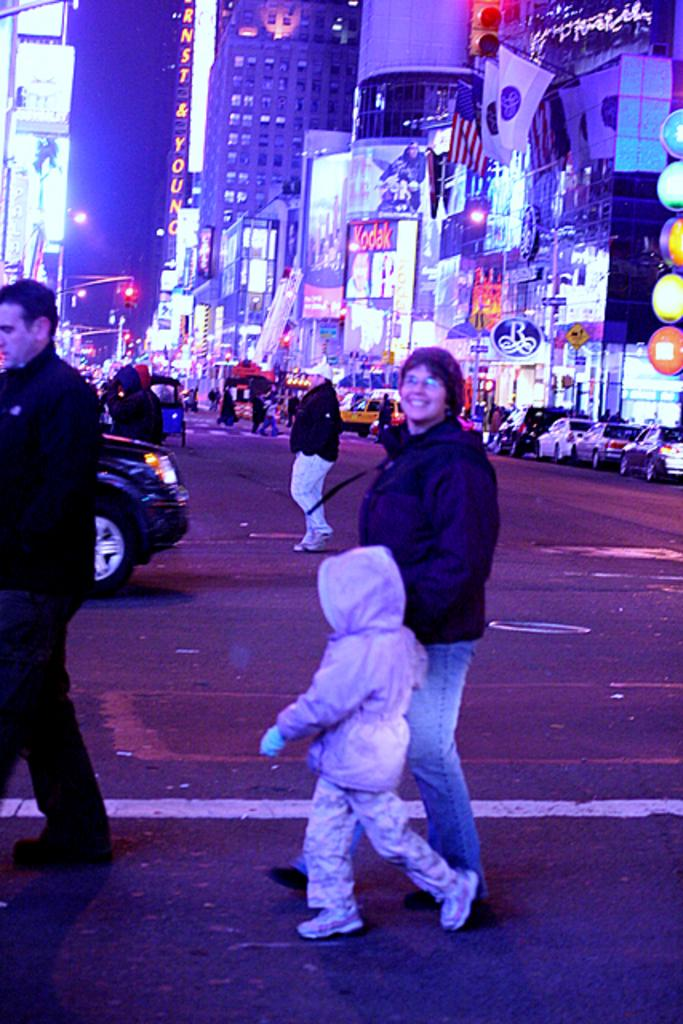What are the people in the image doing? There are persons crossing the road in the image. What can be seen on the right side of the image? There are cars parked on the right side of the image. What structures are visible in the image? There are buildings visible in the image. What type of lighting is present in the image? Street lights are present in the image. How do the vehicles know when to stop or go? Traffic signals are visible in the image to regulate the traffic. How many girls are playing with the earth in the image? There are no girls or earth present in the image. What type of card is being used by the person in the image? There is no card visible in the image. 